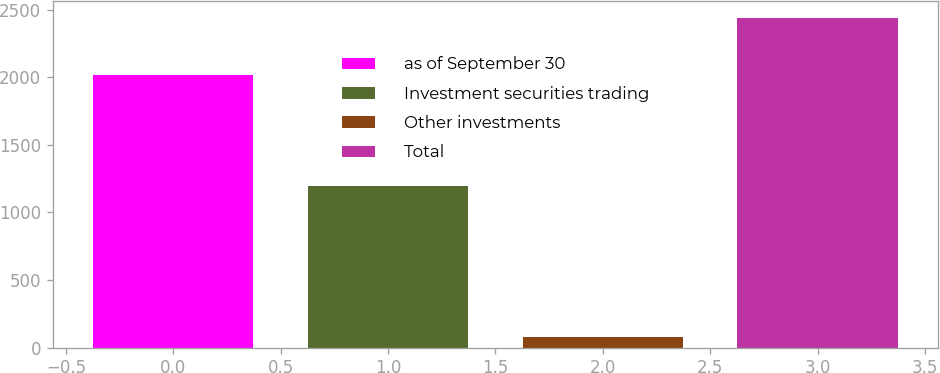<chart> <loc_0><loc_0><loc_500><loc_500><bar_chart><fcel>as of September 30<fcel>Investment securities trading<fcel>Other investments<fcel>Total<nl><fcel>2013<fcel>1196.7<fcel>74.9<fcel>2439.2<nl></chart> 